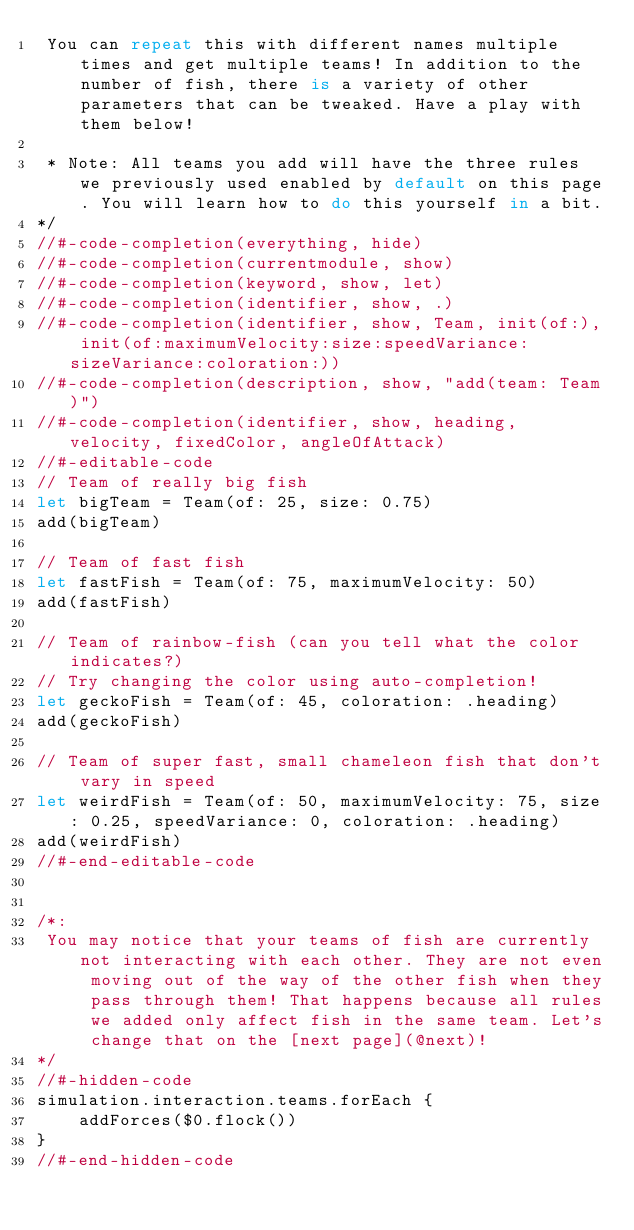Convert code to text. <code><loc_0><loc_0><loc_500><loc_500><_Swift_> You can repeat this with different names multiple times and get multiple teams! In addition to the number of fish, there is a variety of other parameters that can be tweaked. Have a play with them below!

 * Note: All teams you add will have the three rules we previously used enabled by default on this page. You will learn how to do this yourself in a bit.
*/
//#-code-completion(everything, hide)
//#-code-completion(currentmodule, show)
//#-code-completion(keyword, show, let)
//#-code-completion(identifier, show, .)
//#-code-completion(identifier, show, Team, init(of:), init(of:maximumVelocity:size:speedVariance:sizeVariance:coloration:))
//#-code-completion(description, show, "add(team: Team)")
//#-code-completion(identifier, show, heading, velocity, fixedColor, angleOfAttack)
//#-editable-code
// Team of really big fish
let bigTeam = Team(of: 25, size: 0.75)
add(bigTeam)

// Team of fast fish
let fastFish = Team(of: 75, maximumVelocity: 50)
add(fastFish)

// Team of rainbow-fish (can you tell what the color indicates?)
// Try changing the color using auto-completion!
let geckoFish = Team(of: 45, coloration: .heading)
add(geckoFish)

// Team of super fast, small chameleon fish that don't vary in speed
let weirdFish = Team(of: 50, maximumVelocity: 75, size: 0.25, speedVariance: 0, coloration: .heading)
add(weirdFish)
//#-end-editable-code


/*:
 You may notice that your teams of fish are currently not interacting with each other. They are not even moving out of the way of the other fish when they pass through them! That happens because all rules we added only affect fish in the same team. Let's change that on the [next page](@next)!
*/
//#-hidden-code
simulation.interaction.teams.forEach {
    addForces($0.flock())
}
//#-end-hidden-code
</code> 